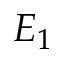Convert formula to latex. <formula><loc_0><loc_0><loc_500><loc_500>E _ { 1 }</formula> 